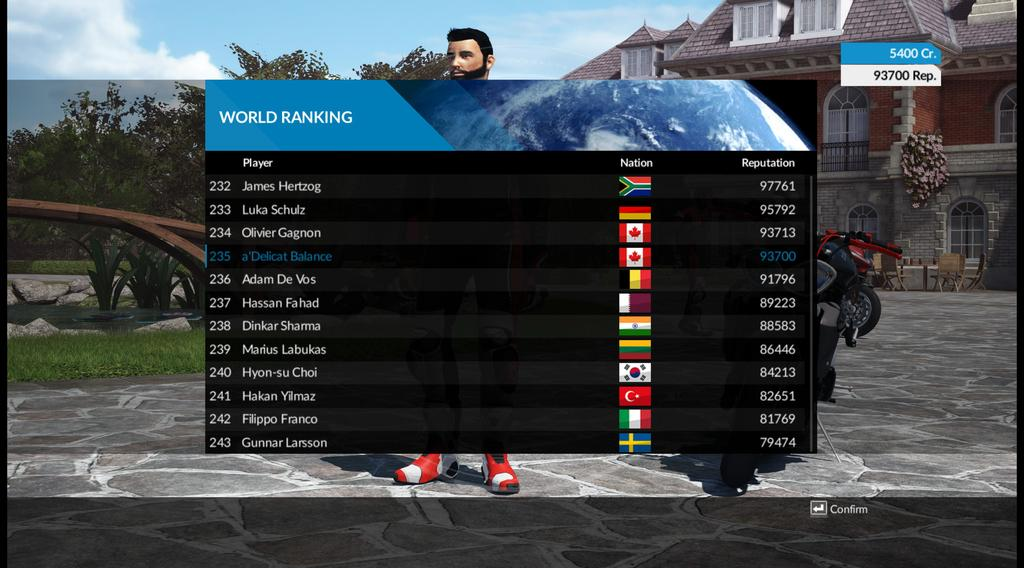Provide a one-sentence caption for the provided image. A video game screen displays the World Ranking stats of players. 